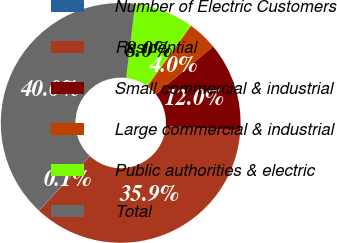<chart> <loc_0><loc_0><loc_500><loc_500><pie_chart><fcel>Number of Electric Customers<fcel>Residential<fcel>Small commercial & industrial<fcel>Large commercial & industrial<fcel>Public authorities & electric<fcel>Total<nl><fcel>0.05%<fcel>35.88%<fcel>12.03%<fcel>4.04%<fcel>8.03%<fcel>39.97%<nl></chart> 